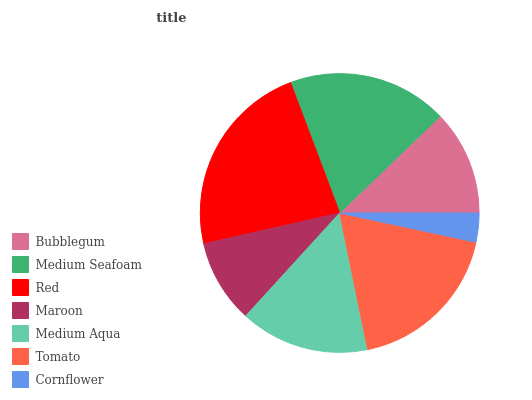Is Cornflower the minimum?
Answer yes or no. Yes. Is Red the maximum?
Answer yes or no. Yes. Is Medium Seafoam the minimum?
Answer yes or no. No. Is Medium Seafoam the maximum?
Answer yes or no. No. Is Medium Seafoam greater than Bubblegum?
Answer yes or no. Yes. Is Bubblegum less than Medium Seafoam?
Answer yes or no. Yes. Is Bubblegum greater than Medium Seafoam?
Answer yes or no. No. Is Medium Seafoam less than Bubblegum?
Answer yes or no. No. Is Medium Aqua the high median?
Answer yes or no. Yes. Is Medium Aqua the low median?
Answer yes or no. Yes. Is Maroon the high median?
Answer yes or no. No. Is Maroon the low median?
Answer yes or no. No. 